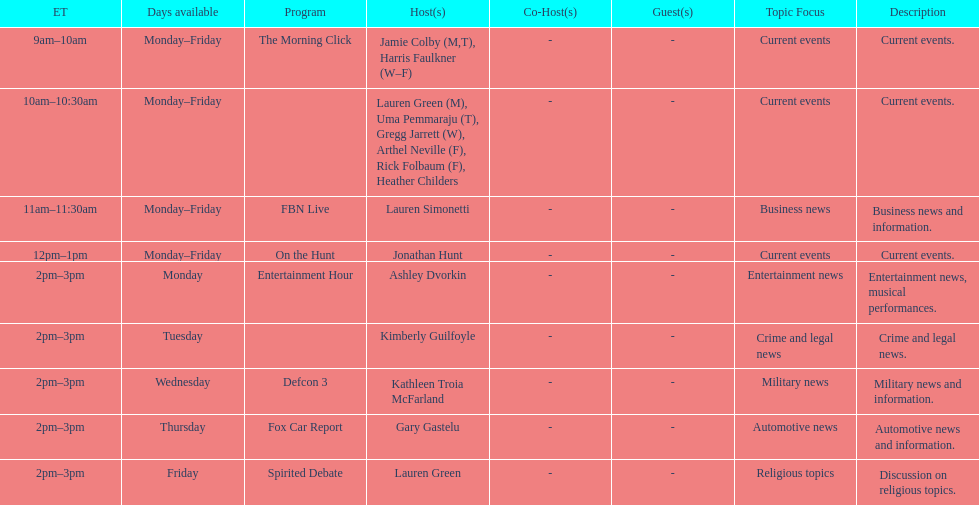Tell me who has her show on fridays at 2. Lauren Green. 